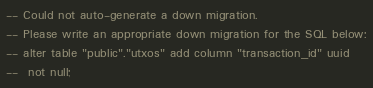Convert code to text. <code><loc_0><loc_0><loc_500><loc_500><_SQL_>-- Could not auto-generate a down migration.
-- Please write an appropriate down migration for the SQL below:
-- alter table "public"."utxos" add column "transaction_id" uuid
--  not null;
</code> 